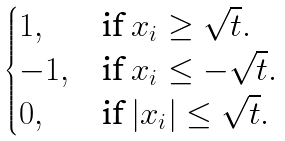Convert formula to latex. <formula><loc_0><loc_0><loc_500><loc_500>\begin{cases} 1 , & \text {if $x_{i} \geq \sqrt{t}$} . \\ - 1 , & \text {if $x_{i} \leq -\sqrt{t}$} . \\ 0 , & \text {if $|x_{i}| \leq \sqrt{t}$} . \end{cases}</formula> 